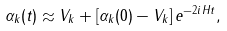<formula> <loc_0><loc_0><loc_500><loc_500>\alpha _ { k } ( t ) \approx V _ { k } + \left [ \alpha _ { k } ( 0 ) - V _ { k } \right ] e ^ { - 2 i H t } ,</formula> 